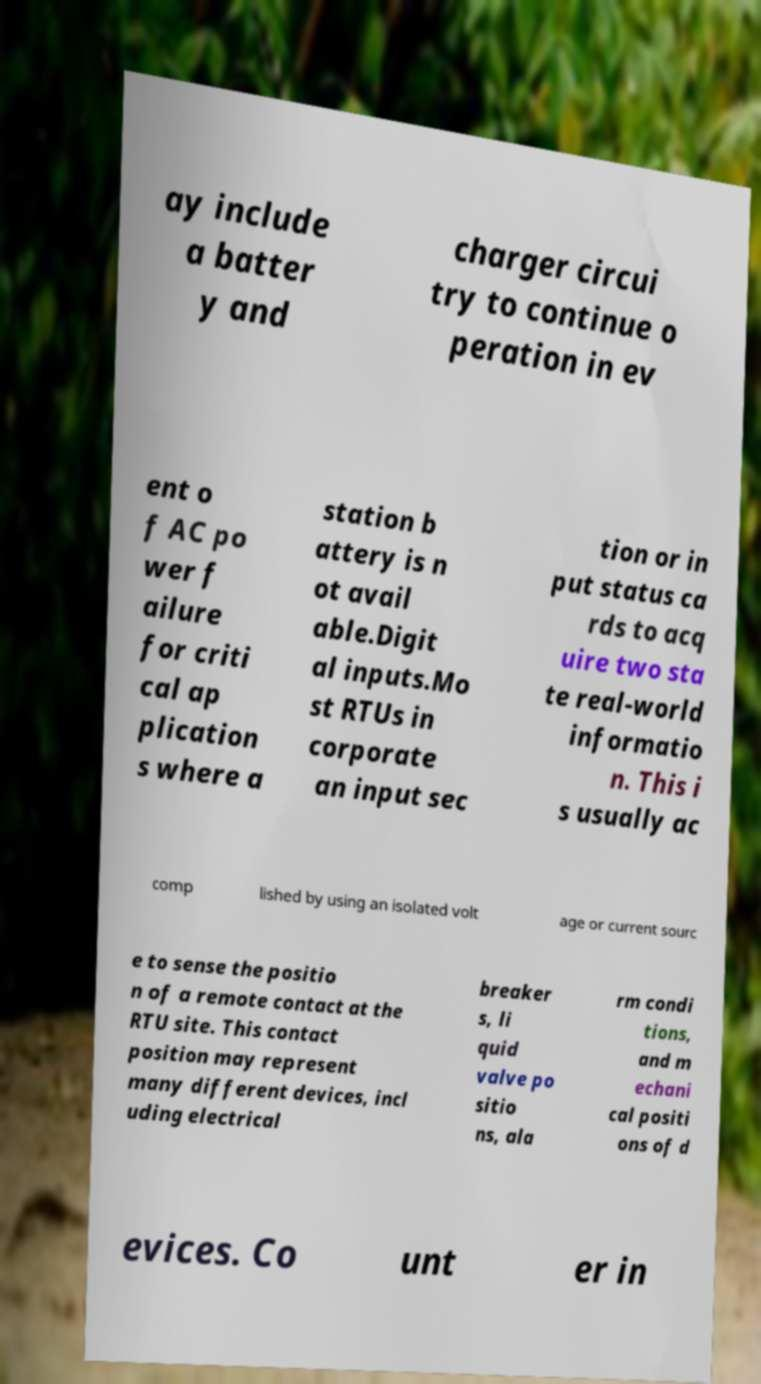Please read and relay the text visible in this image. What does it say? ay include a batter y and charger circui try to continue o peration in ev ent o f AC po wer f ailure for criti cal ap plication s where a station b attery is n ot avail able.Digit al inputs.Mo st RTUs in corporate an input sec tion or in put status ca rds to acq uire two sta te real-world informatio n. This i s usually ac comp lished by using an isolated volt age or current sourc e to sense the positio n of a remote contact at the RTU site. This contact position may represent many different devices, incl uding electrical breaker s, li quid valve po sitio ns, ala rm condi tions, and m echani cal positi ons of d evices. Co unt er in 